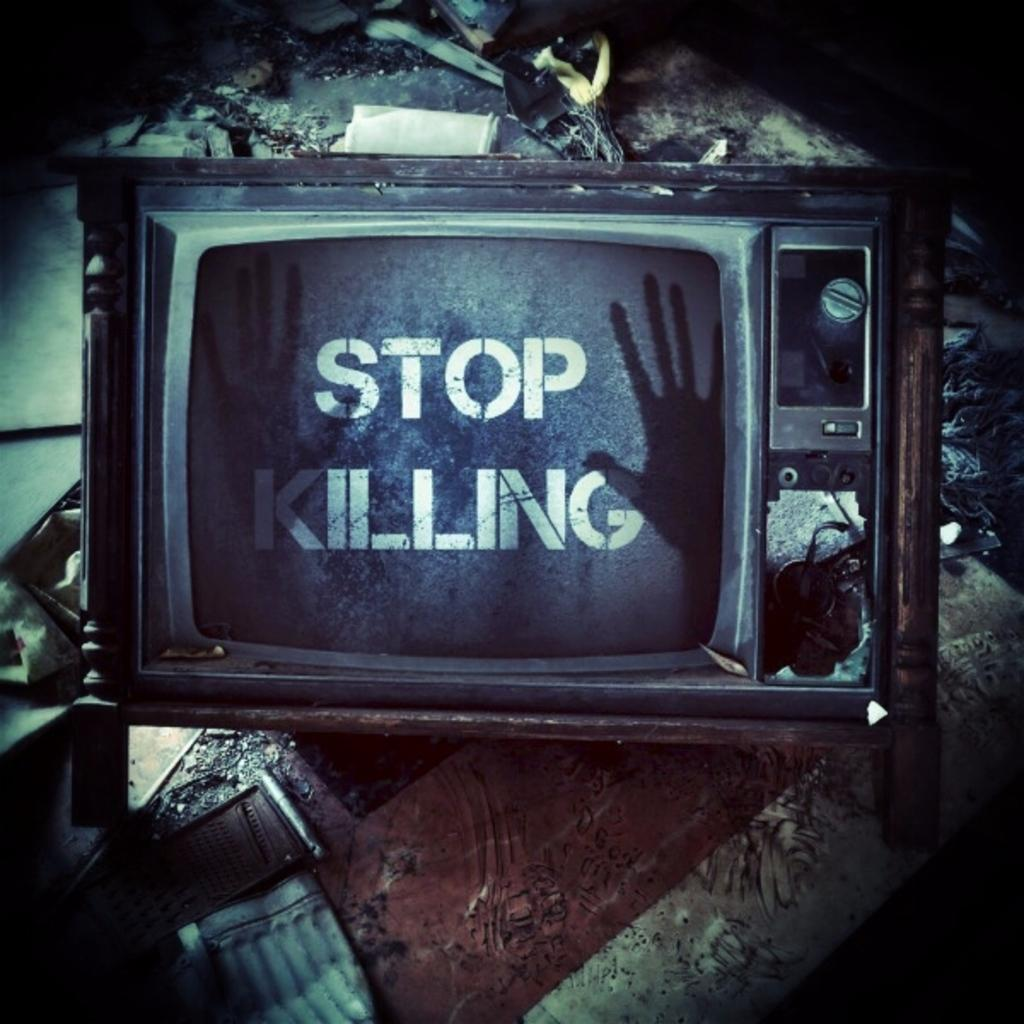What electronic device is present in the image? There is a television in the image. What is displayed on the television screen? Text is visible on the television screen, and a person's hand is also visible. Can you describe any other objects in the background of the image? There are other objects in the background of the image, but their specific details are not mentioned in the provided facts. What type of metal is used to create the magic wand in the image? There is no mention of a magic wand or any metal in the image, so this question cannot be answered definitively. 